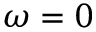<formula> <loc_0><loc_0><loc_500><loc_500>\omega = 0</formula> 